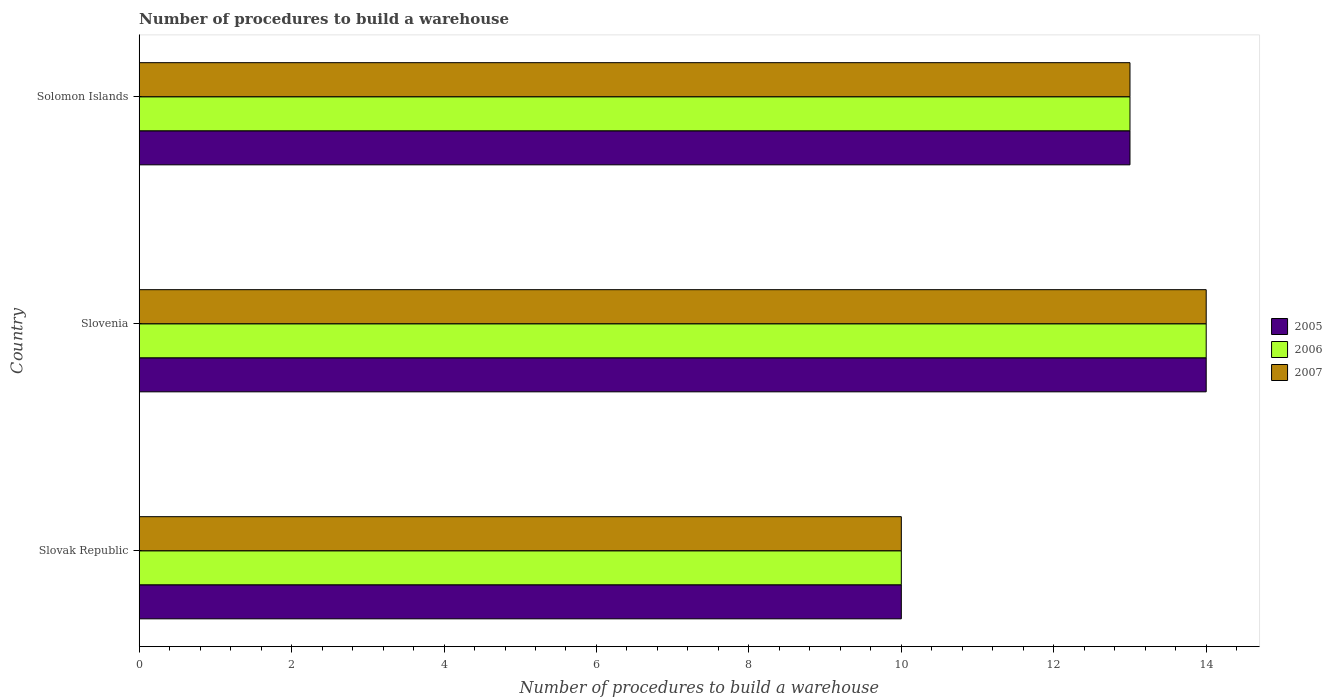How many groups of bars are there?
Keep it short and to the point. 3. Are the number of bars per tick equal to the number of legend labels?
Make the answer very short. Yes. Are the number of bars on each tick of the Y-axis equal?
Ensure brevity in your answer.  Yes. How many bars are there on the 2nd tick from the top?
Keep it short and to the point. 3. How many bars are there on the 2nd tick from the bottom?
Make the answer very short. 3. What is the label of the 3rd group of bars from the top?
Make the answer very short. Slovak Republic. Across all countries, what is the minimum number of procedures to build a warehouse in in 2006?
Offer a terse response. 10. In which country was the number of procedures to build a warehouse in in 2005 maximum?
Make the answer very short. Slovenia. In which country was the number of procedures to build a warehouse in in 2005 minimum?
Your answer should be very brief. Slovak Republic. What is the total number of procedures to build a warehouse in in 2005 in the graph?
Offer a very short reply. 37. What is the difference between the number of procedures to build a warehouse in in 2007 in Slovak Republic and the number of procedures to build a warehouse in in 2006 in Solomon Islands?
Provide a short and direct response. -3. What is the average number of procedures to build a warehouse in in 2007 per country?
Provide a short and direct response. 12.33. What is the difference between the number of procedures to build a warehouse in in 2007 and number of procedures to build a warehouse in in 2006 in Slovenia?
Keep it short and to the point. 0. What is the ratio of the number of procedures to build a warehouse in in 2007 in Slovak Republic to that in Solomon Islands?
Your response must be concise. 0.77. What is the difference between the highest and the second highest number of procedures to build a warehouse in in 2005?
Ensure brevity in your answer.  1. What does the 3rd bar from the top in Slovenia represents?
Ensure brevity in your answer.  2005. What does the 1st bar from the bottom in Solomon Islands represents?
Your answer should be compact. 2005. How many bars are there?
Keep it short and to the point. 9. How many countries are there in the graph?
Give a very brief answer. 3. How many legend labels are there?
Give a very brief answer. 3. How are the legend labels stacked?
Your response must be concise. Vertical. What is the title of the graph?
Offer a terse response. Number of procedures to build a warehouse. What is the label or title of the X-axis?
Provide a succinct answer. Number of procedures to build a warehouse. What is the Number of procedures to build a warehouse in 2005 in Slovak Republic?
Offer a very short reply. 10. What is the Number of procedures to build a warehouse of 2006 in Slovak Republic?
Give a very brief answer. 10. What is the Number of procedures to build a warehouse of 2007 in Slovak Republic?
Give a very brief answer. 10. What is the Number of procedures to build a warehouse of 2006 in Slovenia?
Ensure brevity in your answer.  14. What is the Number of procedures to build a warehouse in 2007 in Slovenia?
Your response must be concise. 14. What is the Number of procedures to build a warehouse of 2006 in Solomon Islands?
Your answer should be very brief. 13. What is the Number of procedures to build a warehouse of 2007 in Solomon Islands?
Offer a very short reply. 13. Across all countries, what is the maximum Number of procedures to build a warehouse of 2006?
Offer a very short reply. 14. Across all countries, what is the maximum Number of procedures to build a warehouse in 2007?
Make the answer very short. 14. Across all countries, what is the minimum Number of procedures to build a warehouse in 2005?
Provide a succinct answer. 10. What is the difference between the Number of procedures to build a warehouse in 2007 in Slovak Republic and that in Slovenia?
Your answer should be very brief. -4. What is the difference between the Number of procedures to build a warehouse in 2006 in Slovak Republic and that in Solomon Islands?
Keep it short and to the point. -3. What is the difference between the Number of procedures to build a warehouse in 2006 in Slovenia and that in Solomon Islands?
Provide a succinct answer. 1. What is the difference between the Number of procedures to build a warehouse of 2007 in Slovenia and that in Solomon Islands?
Provide a succinct answer. 1. What is the difference between the Number of procedures to build a warehouse in 2006 in Slovak Republic and the Number of procedures to build a warehouse in 2007 in Slovenia?
Keep it short and to the point. -4. What is the difference between the Number of procedures to build a warehouse of 2006 in Slovak Republic and the Number of procedures to build a warehouse of 2007 in Solomon Islands?
Ensure brevity in your answer.  -3. What is the difference between the Number of procedures to build a warehouse of 2005 in Slovenia and the Number of procedures to build a warehouse of 2007 in Solomon Islands?
Provide a succinct answer. 1. What is the average Number of procedures to build a warehouse in 2005 per country?
Offer a very short reply. 12.33. What is the average Number of procedures to build a warehouse of 2006 per country?
Your answer should be compact. 12.33. What is the average Number of procedures to build a warehouse in 2007 per country?
Provide a succinct answer. 12.33. What is the difference between the Number of procedures to build a warehouse of 2005 and Number of procedures to build a warehouse of 2006 in Slovak Republic?
Your response must be concise. 0. What is the difference between the Number of procedures to build a warehouse of 2005 and Number of procedures to build a warehouse of 2007 in Slovak Republic?
Your response must be concise. 0. What is the difference between the Number of procedures to build a warehouse of 2005 and Number of procedures to build a warehouse of 2006 in Slovenia?
Give a very brief answer. 0. What is the difference between the Number of procedures to build a warehouse of 2005 and Number of procedures to build a warehouse of 2007 in Slovenia?
Your answer should be compact. 0. What is the difference between the Number of procedures to build a warehouse of 2006 and Number of procedures to build a warehouse of 2007 in Slovenia?
Provide a succinct answer. 0. What is the ratio of the Number of procedures to build a warehouse of 2005 in Slovak Republic to that in Slovenia?
Provide a succinct answer. 0.71. What is the ratio of the Number of procedures to build a warehouse in 2005 in Slovak Republic to that in Solomon Islands?
Ensure brevity in your answer.  0.77. What is the ratio of the Number of procedures to build a warehouse in 2006 in Slovak Republic to that in Solomon Islands?
Make the answer very short. 0.77. What is the ratio of the Number of procedures to build a warehouse of 2007 in Slovak Republic to that in Solomon Islands?
Give a very brief answer. 0.77. What is the ratio of the Number of procedures to build a warehouse of 2005 in Slovenia to that in Solomon Islands?
Ensure brevity in your answer.  1.08. What is the ratio of the Number of procedures to build a warehouse of 2006 in Slovenia to that in Solomon Islands?
Your answer should be compact. 1.08. What is the ratio of the Number of procedures to build a warehouse of 2007 in Slovenia to that in Solomon Islands?
Your response must be concise. 1.08. What is the difference between the highest and the second highest Number of procedures to build a warehouse of 2006?
Give a very brief answer. 1. What is the difference between the highest and the lowest Number of procedures to build a warehouse of 2005?
Keep it short and to the point. 4. 